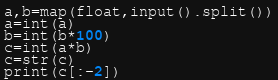<code> <loc_0><loc_0><loc_500><loc_500><_Python_>a,b=map(float,input().split())
a=int(a)
b=int(b*100)
c=int(a*b)
c=str(c)
print(c[:-2])</code> 